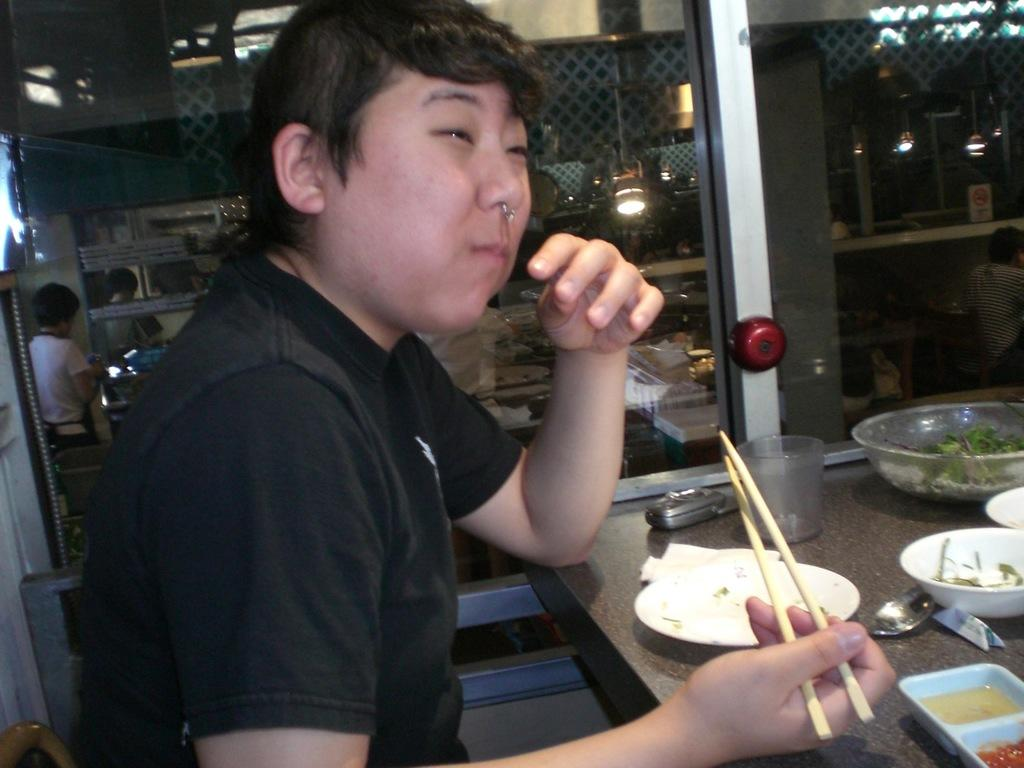What is the person in the image holding? The person in the image is holding chopsticks. What objects are on the table in the image? There are plates, a phone, and a glass on the table in the image. Can you describe the background of the image? There are people visible in the background of the image. What type of paint is the person using to grip the chopsticks in the image? There is no paint or gripping technique mentioned in the image; the person is simply holding chopsticks. 